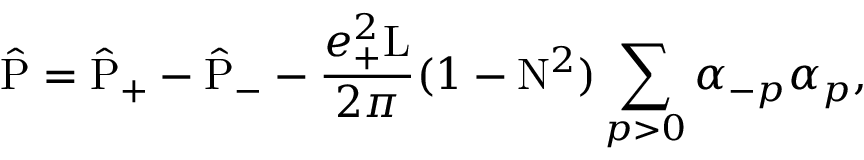<formula> <loc_0><loc_0><loc_500><loc_500>\hat { P } = \hat { P } _ { + } - \hat { P } _ { - } - \frac { e _ { + } ^ { 2 } L } { 2 \pi } ( 1 - N ^ { 2 } ) \sum _ { p > 0 } { \alpha } _ { - p } { \alpha } _ { p } ,</formula> 